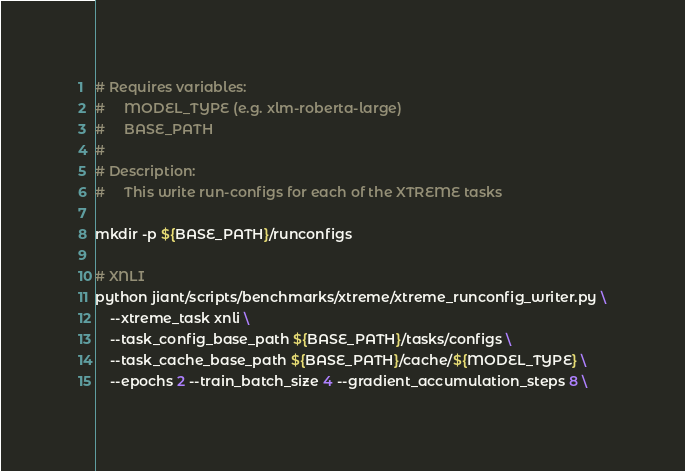<code> <loc_0><loc_0><loc_500><loc_500><_Bash_># Requires variables:
#     MODEL_TYPE (e.g. xlm-roberta-large)
#     BASE_PATH
#
# Description:
#     This write run-configs for each of the XTREME tasks

mkdir -p ${BASE_PATH}/runconfigs

# XNLI
python jiant/scripts/benchmarks/xtreme/xtreme_runconfig_writer.py \
    --xtreme_task xnli \
    --task_config_base_path ${BASE_PATH}/tasks/configs \
    --task_cache_base_path ${BASE_PATH}/cache/${MODEL_TYPE} \
    --epochs 2 --train_batch_size 4 --gradient_accumulation_steps 8 \</code> 